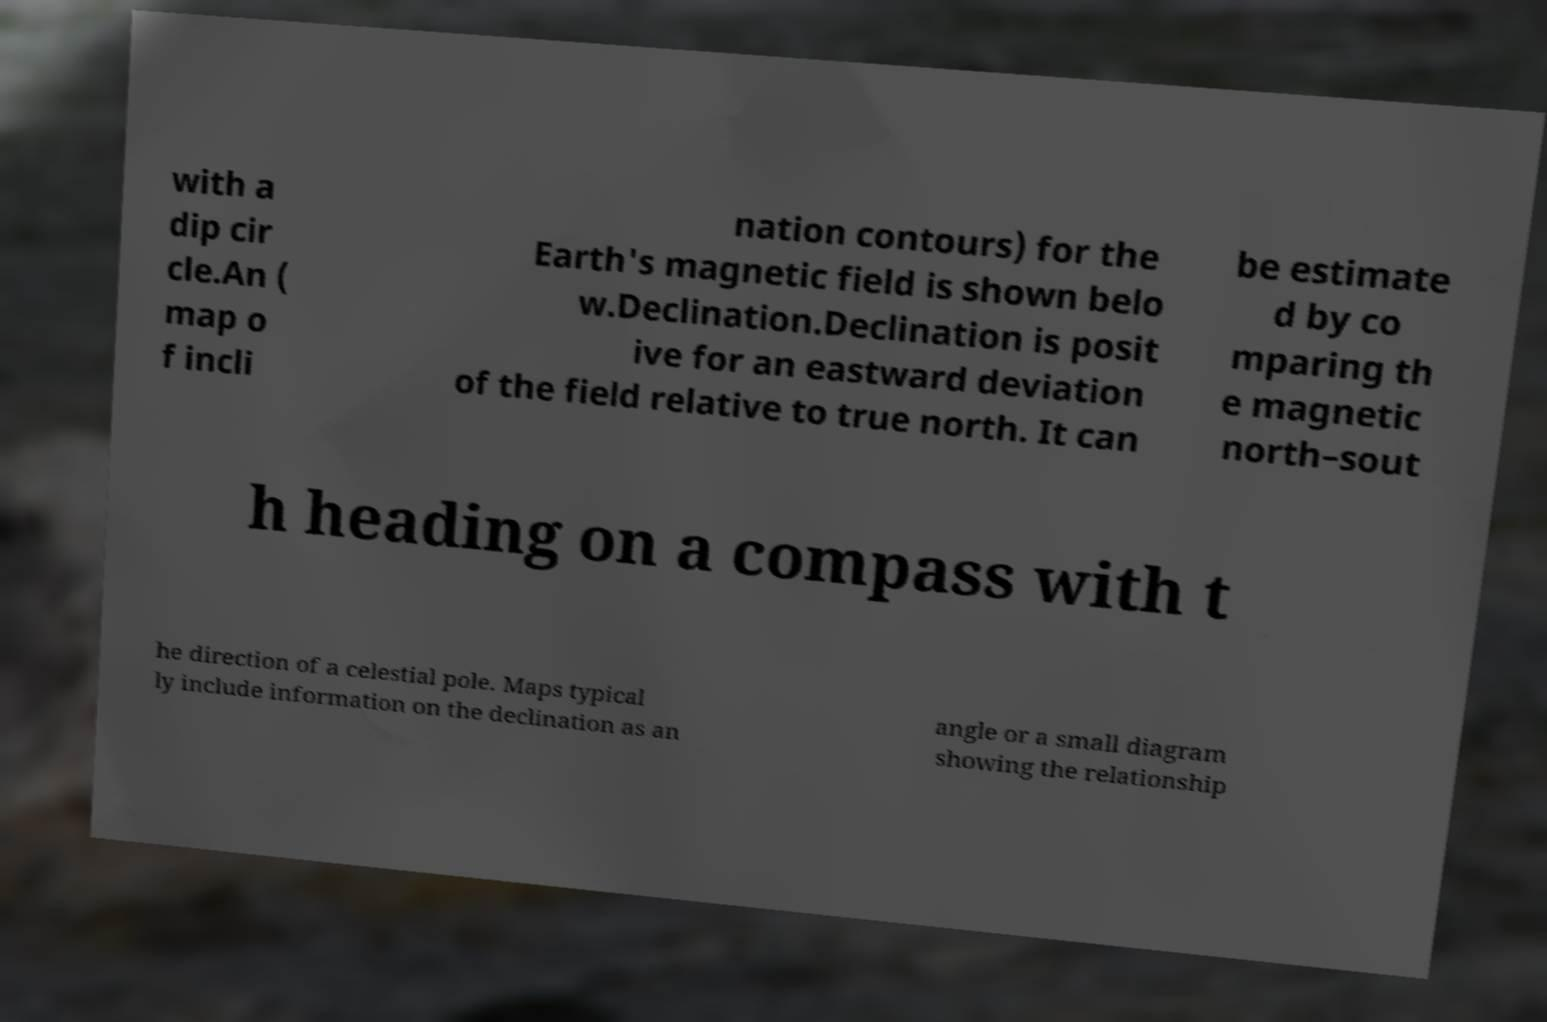Could you assist in decoding the text presented in this image and type it out clearly? with a dip cir cle.An ( map o f incli nation contours) for the Earth's magnetic field is shown belo w.Declination.Declination is posit ive for an eastward deviation of the field relative to true north. It can be estimate d by co mparing th e magnetic north–sout h heading on a compass with t he direction of a celestial pole. Maps typical ly include information on the declination as an angle or a small diagram showing the relationship 